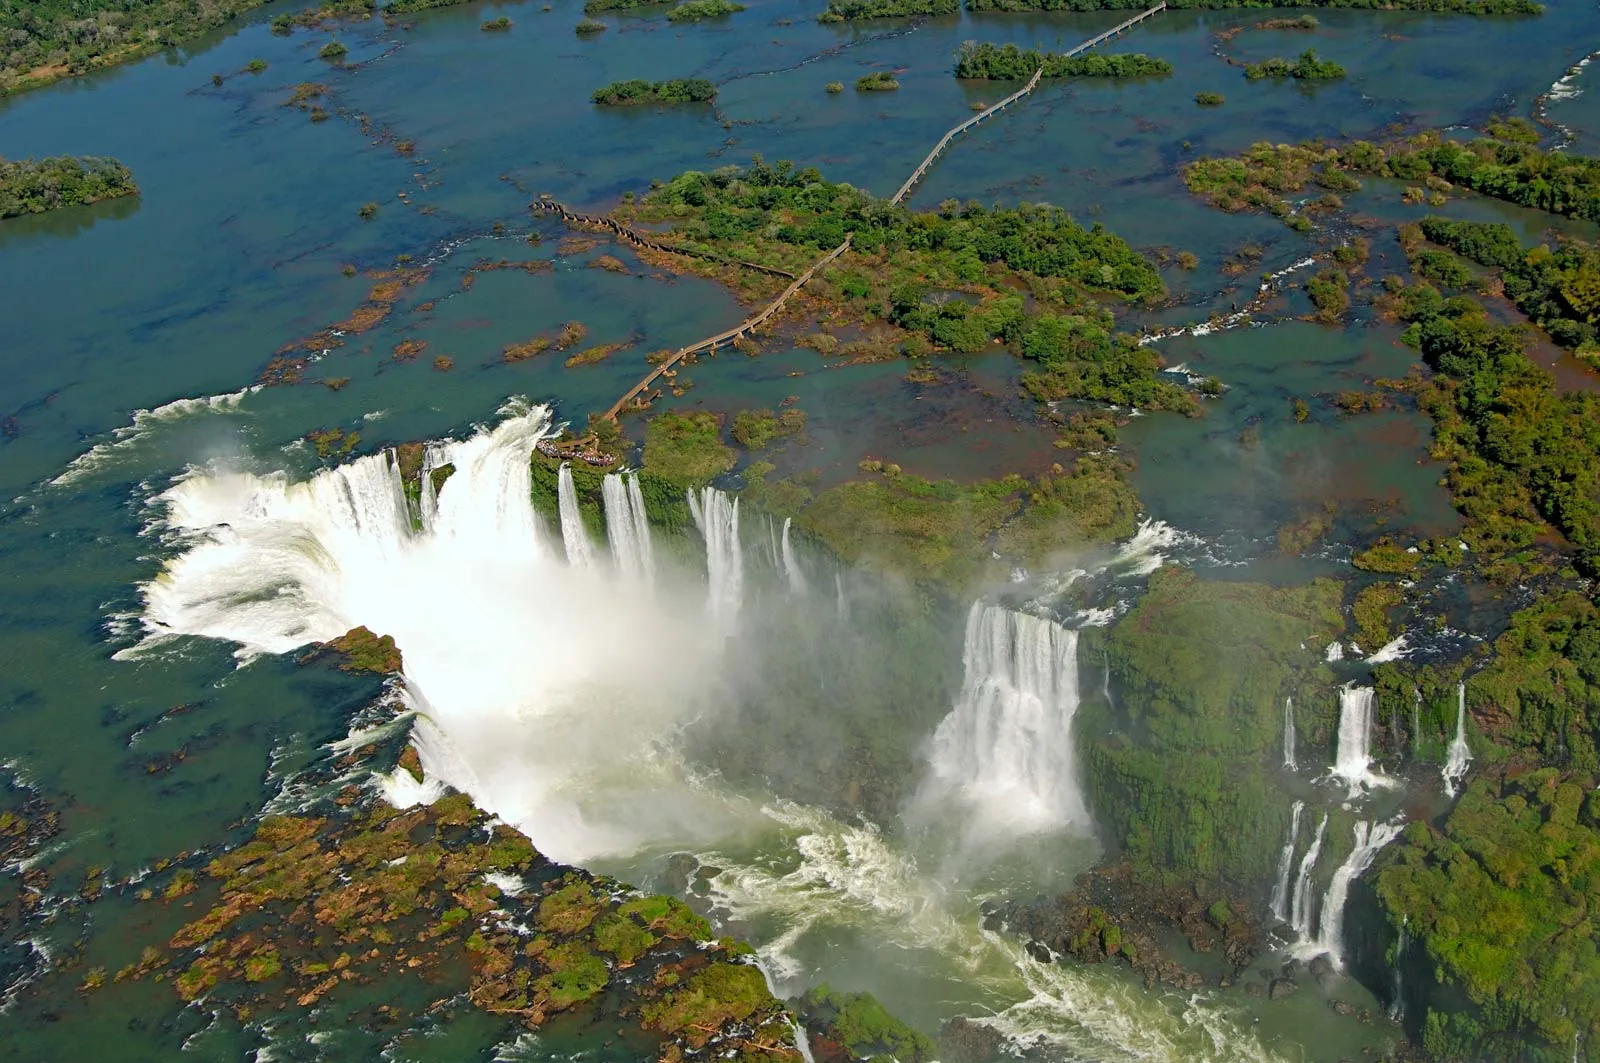What are the key elements in this picture? This image captures the breathtaking view of the Iguazu Falls, a natural wonder straddling the border of Argentina and Brazil. From an aerial perspective, we look down upon the powerful cascade of water, with its frothy white torrents contrasting starkly against the calm blue-green expanse of the surrounding water. The falls are encircled by lush, verdant greenery, with misty sprays rising dramatically to meet the viewer's gaze. This scene encapsulates a magnificent interplay of raw, natural power and serene, picturesque beauty, highlighting the awe-inspiring splendor of our planet’s landscapes. 